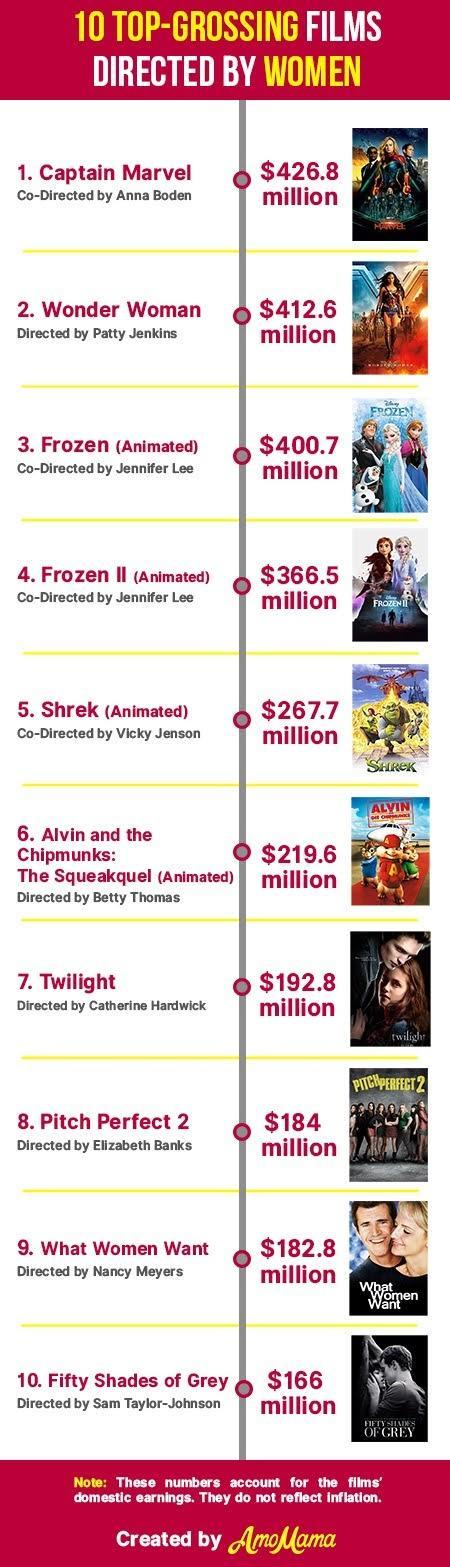How many movies were co-directed by Jennifer Lee?
Answer the question with a short phrase. 2 How many of the animated movies were produced by Disney? 2 How many women directors are listed in this table? 9 How many movies are animation movies ? 4 